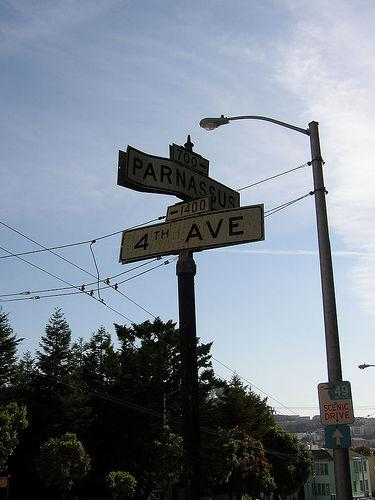Question: where is this scene taking place?
Choices:
A. In a castle.
B. At the zoo.
C. On a boat.
D. At a crossroad.
Answer with the letter. Answer: D Question: how many people are visible in this scene?
Choices:
A. None.
B. One.
C. Two.
D. Three.
Answer with the letter. Answer: A Question: what is the tall object on the right side of the photo with the street sign attached to it?
Choices:
A. Building.
B. Street light.
C. Post.
D. Pole.
Answer with the letter. Answer: B Question: what does the red words on the street sign attached to the street light on the right side of the photo say?
Choices:
A. Curves.
B. Scenic drive.
C. Do Not Enter.
D. Danger.
Answer with the letter. Answer: B Question: what are the lines attached to the street light hanging in the air?
Choices:
A. Electrical lines.
B. Telephone lines.
C. Christmas lights.
D. Power lines.
Answer with the letter. Answer: D Question: what color is the sky?
Choices:
A. Orange.
B. Purple.
C. Grey.
D. Blue and white.
Answer with the letter. Answer: D 